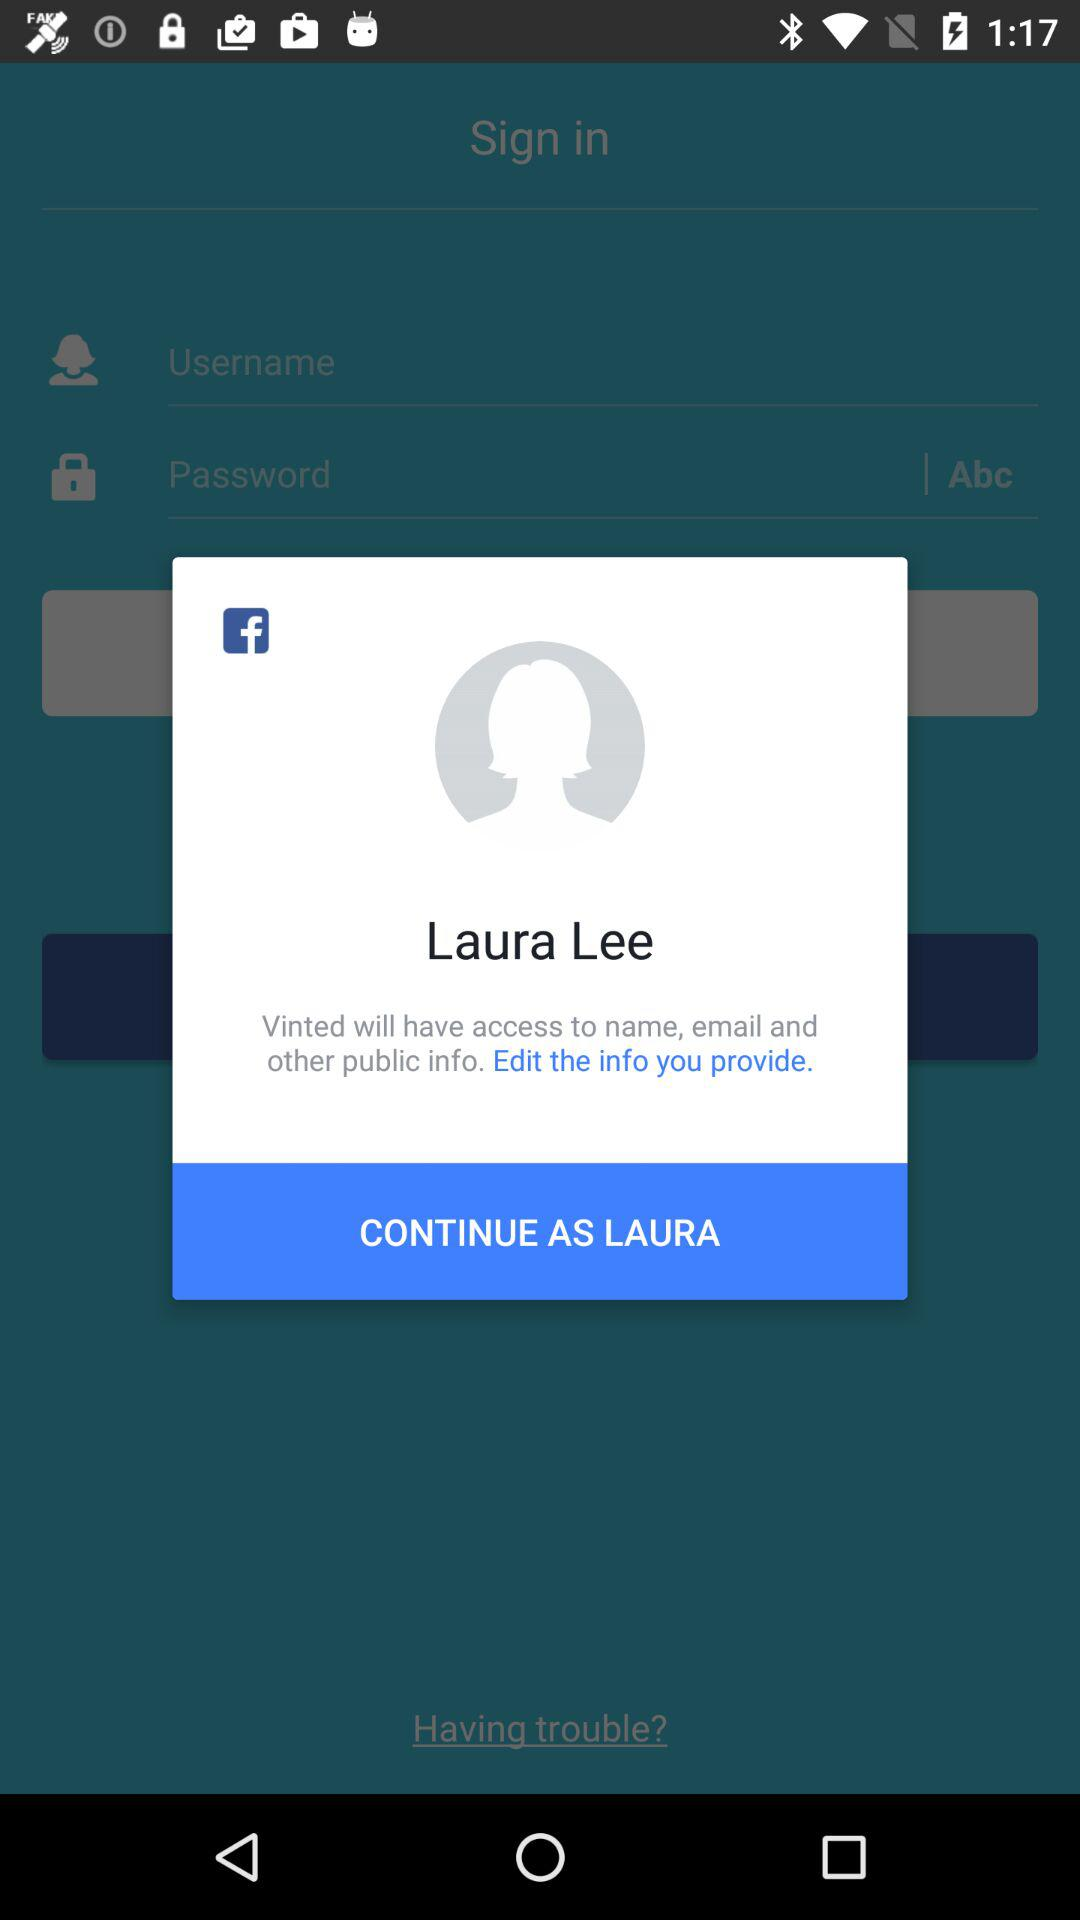Which information will "Vinted" access? "Vinted" will have access to name, email and other public information. 